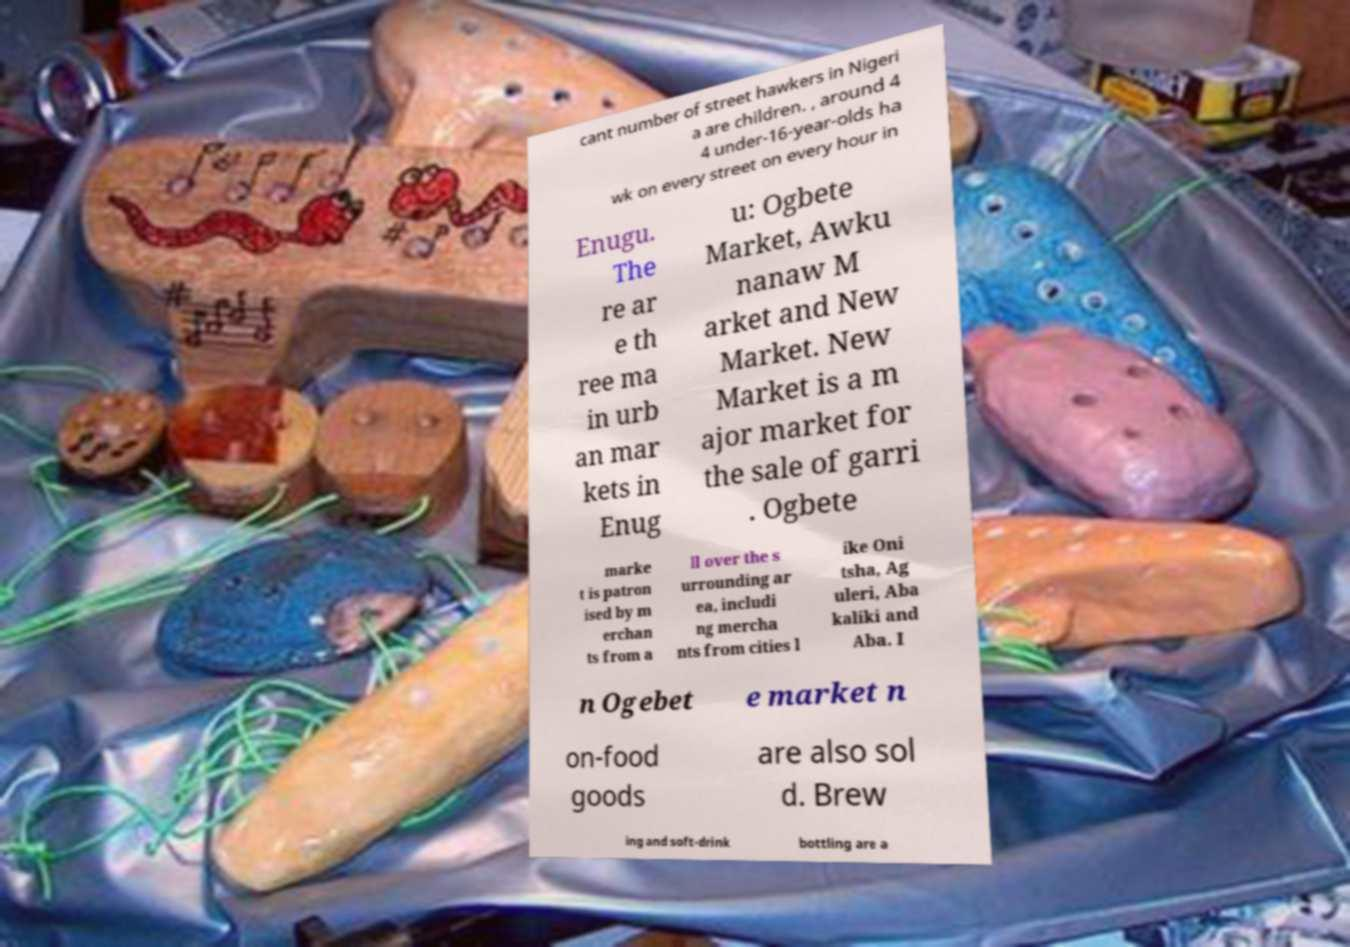Can you read and provide the text displayed in the image?This photo seems to have some interesting text. Can you extract and type it out for me? cant number of street hawkers in Nigeri a are children. , around 4 4 under-16-year-olds ha wk on every street on every hour in Enugu. The re ar e th ree ma in urb an mar kets in Enug u: Ogbete Market, Awku nanaw M arket and New Market. New Market is a m ajor market for the sale of garri . Ogbete marke t is patron ised by m erchan ts from a ll over the s urrounding ar ea, includi ng mercha nts from cities l ike Oni tsha, Ag uleri, Aba kaliki and Aba. I n Ogebet e market n on-food goods are also sol d. Brew ing and soft-drink bottling are a 